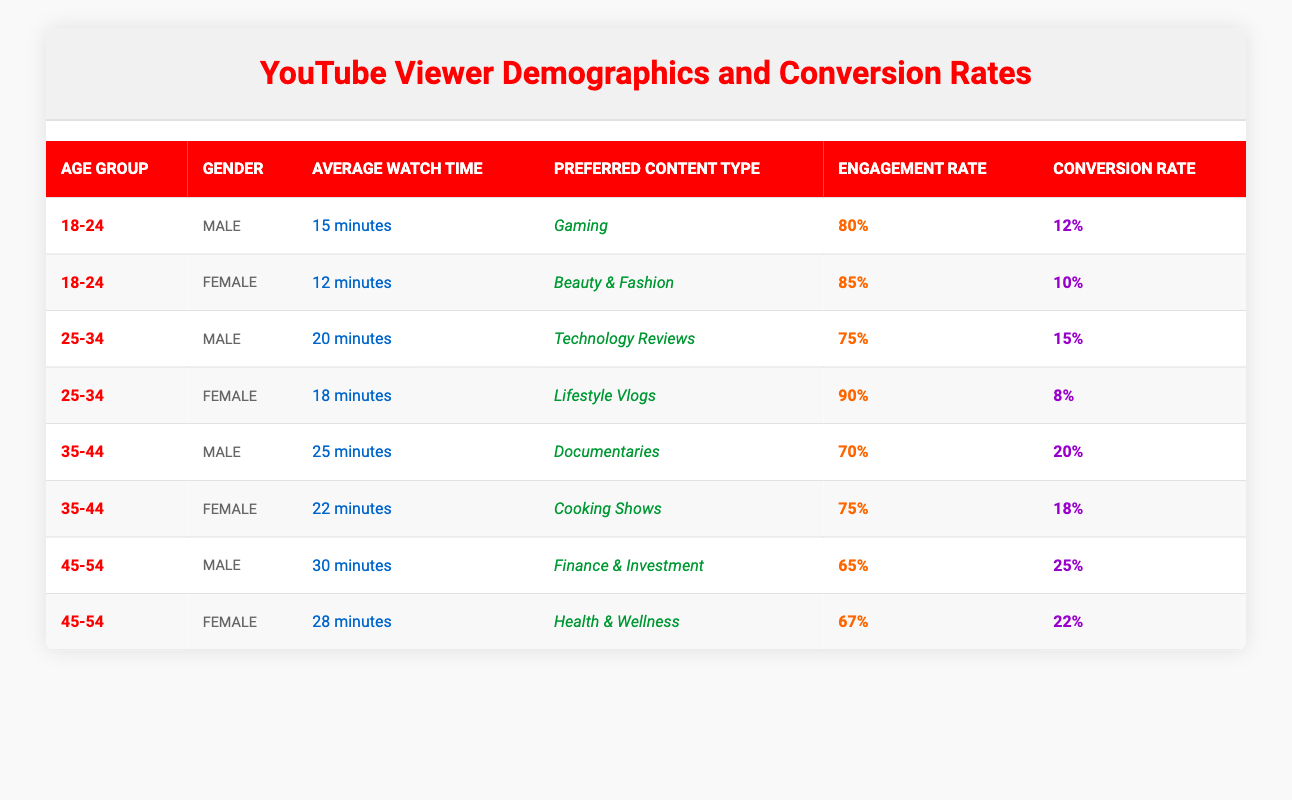What is the preferred content type for viewers aged 35-44 who are female? According to the table, the preferred content type for female viewers aged 35-44 is "Cooking Shows."
Answer: Cooking Shows Which age group has the highest engagement rate among male viewers? From the data, male viewers aged 18-24 have an engagement rate of 80%, and male viewers aged 45-54 have a lower engagement rate of 65%. So, the highest engagement rate among male viewers is for the 18-24 age group.
Answer: 18-24 What is the average watch time for female viewers across all age groups? By adding the average watch times for female viewers: 12 (18-24) + 18 (25-34) + 22 (35-44) + 28 (45-54) = 80 minutes. There are 4 female viewers, so the average watch time is 80/4 = 20 minutes.
Answer: 20 minutes Is the conversion rate for male viewers aged 45-54 higher than that for female viewers in the same age group? The conversion rate for male viewers aged 45-54 is 25%, while for female viewers it is 22%. Since 25% is greater than 22%, the statement is true.
Answer: Yes What is the relationship between average watch time and conversion rate for viewers aged 25-34? Male viewers aged 25-34 have an average watch time of 20 minutes and a conversion rate of 15%. Female viewers in the same age group have an average watch time of 18 minutes and a conversion rate of 8%. Here, higher watch time corresponds with a higher conversion rate for male viewers but not for females, indicating a different viewer behavior.
Answer: Varies by gender How many minutes do male viewers spend watching content related to "Finance & Investment"? The average watch time for male viewers interested in Finance & Investment is 30 minutes, as shown in the table.
Answer: 30 minutes Which content type has the lowest engagement rate and what is it? The content type with the lowest engagement rate is "Finance & Investment" with an engagement rate of 65% for male viewers.
Answer: Finance & Investment - 65% What is the conversion rate difference between male and female viewers aged 35-44? The conversion rate for male viewers aged 35-44 is 20%, and for female viewers, it is 18%. The difference is 20% - 18% = 2%.
Answer: 2% In which age group do viewers have the longest average watch time? Among all age groups, male viewers aged 45-54 have the longest average watch time of 30 minutes, making them the highest in this metric.
Answer: 45-54 